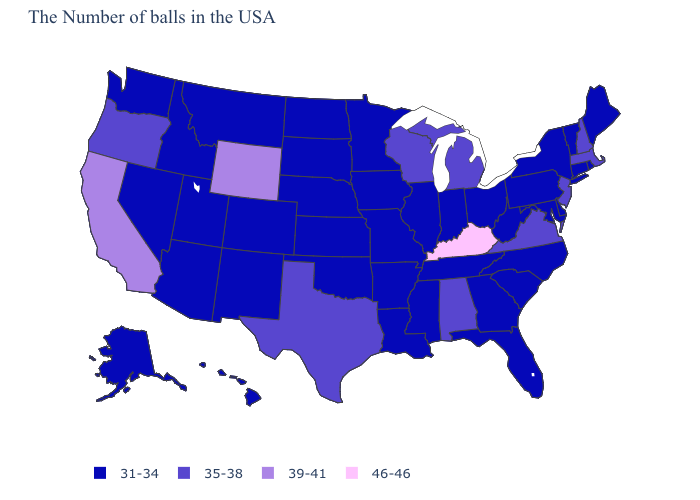Among the states that border South Dakota , which have the highest value?
Keep it brief. Wyoming. Name the states that have a value in the range 35-38?
Short answer required. Massachusetts, New Hampshire, New Jersey, Virginia, Michigan, Alabama, Wisconsin, Texas, Oregon. Which states hav the highest value in the MidWest?
Short answer required. Michigan, Wisconsin. Name the states that have a value in the range 35-38?
Give a very brief answer. Massachusetts, New Hampshire, New Jersey, Virginia, Michigan, Alabama, Wisconsin, Texas, Oregon. Does Kentucky have the highest value in the USA?
Answer briefly. Yes. Which states have the highest value in the USA?
Answer briefly. Kentucky. Among the states that border Kentucky , does Virginia have the lowest value?
Keep it brief. No. What is the value of Virginia?
Write a very short answer. 35-38. What is the value of Rhode Island?
Give a very brief answer. 31-34. What is the highest value in the West ?
Answer briefly. 39-41. Name the states that have a value in the range 31-34?
Be succinct. Maine, Rhode Island, Vermont, Connecticut, New York, Delaware, Maryland, Pennsylvania, North Carolina, South Carolina, West Virginia, Ohio, Florida, Georgia, Indiana, Tennessee, Illinois, Mississippi, Louisiana, Missouri, Arkansas, Minnesota, Iowa, Kansas, Nebraska, Oklahoma, South Dakota, North Dakota, Colorado, New Mexico, Utah, Montana, Arizona, Idaho, Nevada, Washington, Alaska, Hawaii. What is the highest value in states that border Georgia?
Quick response, please. 35-38. Name the states that have a value in the range 39-41?
Give a very brief answer. Wyoming, California. Does Kansas have the lowest value in the MidWest?
Write a very short answer. Yes. Is the legend a continuous bar?
Write a very short answer. No. 